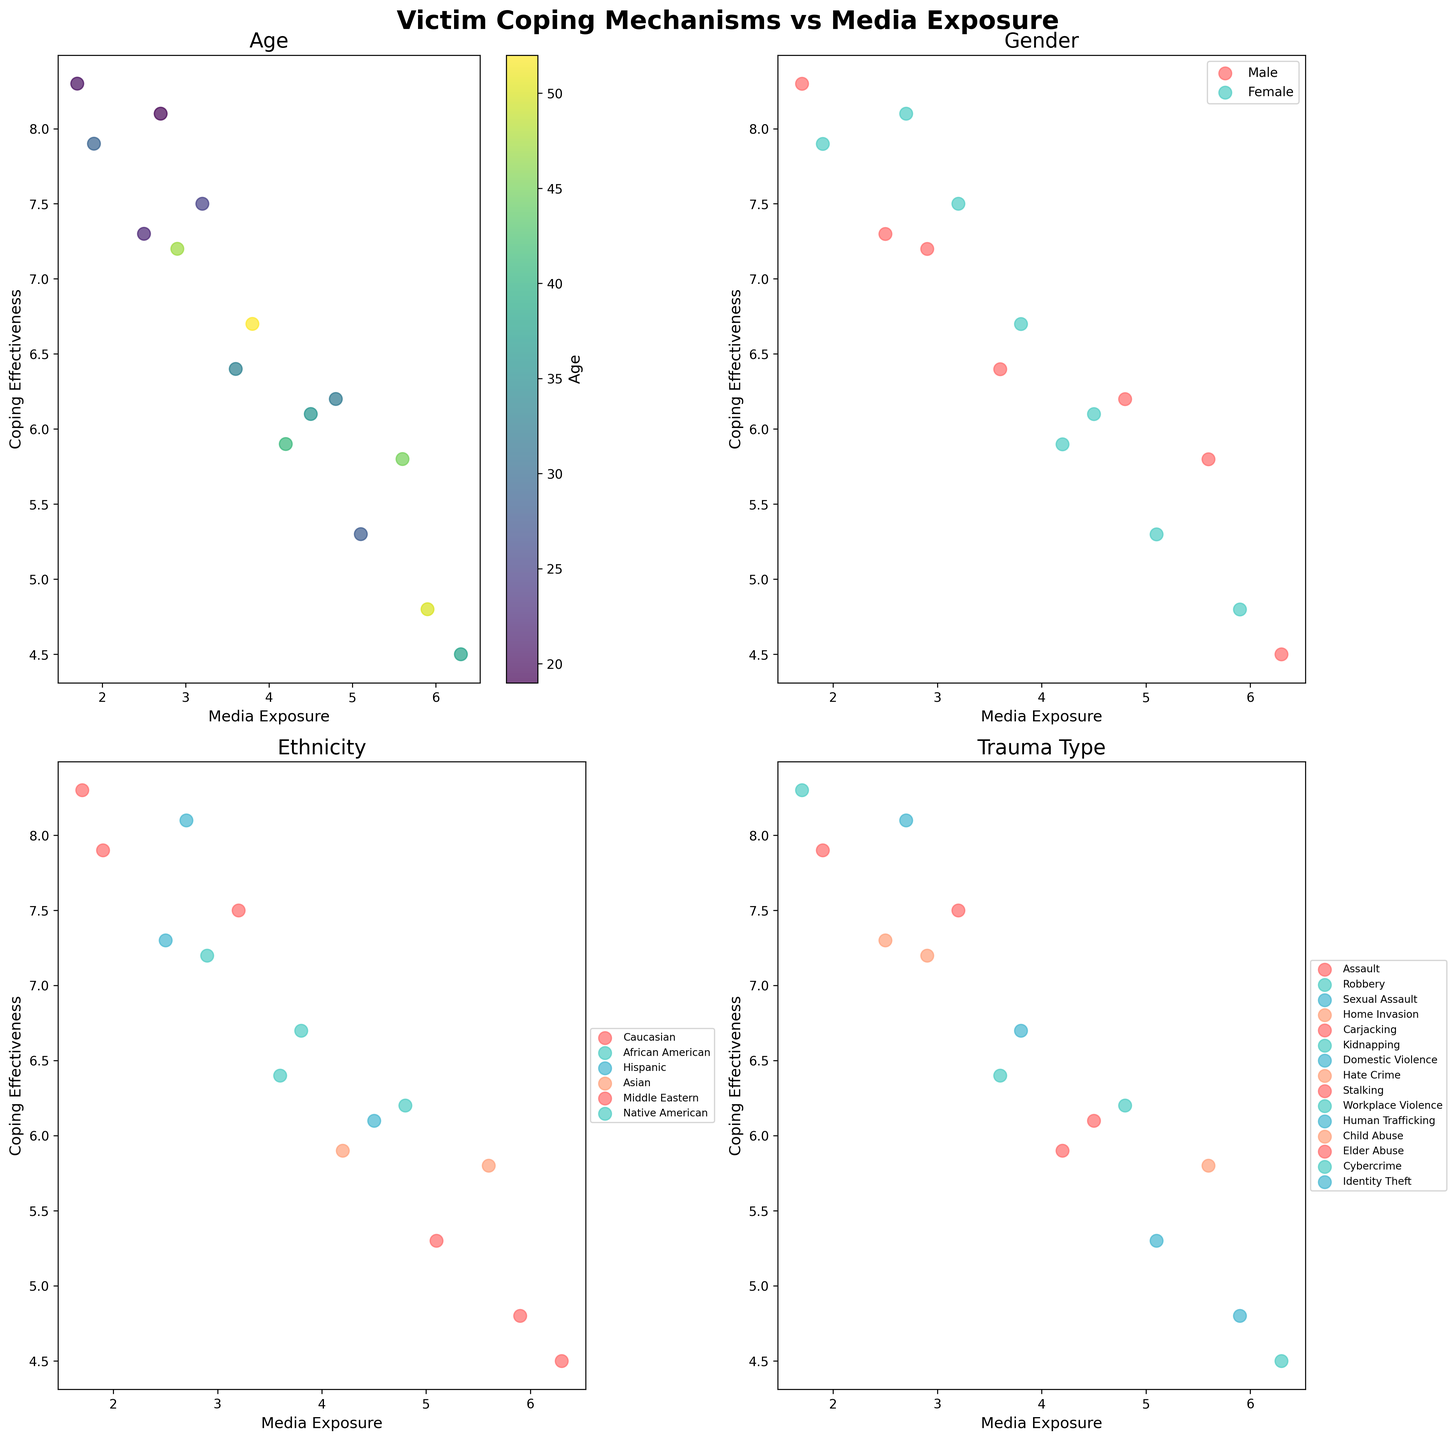What is the title of the figure? The title of the figure distinguishes and summarizes the overall content, specifically seen at the figure's top, styled prominently.
Answer: Victim Coping Mechanisms vs Media Exposure Which demographic group has the highest number of data points in the Ethnicity subplot? In the Ethnicity subplot, count the number of points associated with each unique ethnicity's color in the legend.
Answer: Caucasian How do coping effectiveness and media exposure relate for victims in the Age subplot? Examine the first subplot where Age is the variable represented by a color gradient; look for general trends or patterns in coping effectiveness relative to media exposure values.
Answer: Older victims tend to have lower coping effectiveness with higher media exposure Is there a noticeable difference in coping effectiveness between males and females based on the Gender subplot? Comparing the clustering of data points representing males and females in the Gender subplot helps identify variations in coping effectiveness.
Answer: Yes, females generally have higher coping effectiveness Which trauma type indicates the lowest coping effectiveness with high media exposure? Check the Trauma Type subplot for the data point indicating the highest media exposure and the respective coping effectiveness, paired with the legend color corresponding to trauma type.
Answer: Identity Theft Does higher media exposure always correlate with lower coping effectiveness in any subplot? Compare scatter plots across different demographics by observing whether points with high media exposure consistently show low coping effectiveness.
Answer: No, not always What is the age range displayed in the Age subplot? By observing the range of colors in the Age subplot and the corresponding color bar, infer the minimum and maximum ages among the data points.
Answer: 19 - 52 Which subplot shows the most diverse range of coping effectiveness and media exposure values? Review each subplot and compare the spread and range of data points for coping effectiveness and media exposure.
Answer: Age How does the coping effectiveness of African American victims compare to Hispanic victims given their media exposure levels? In the Ethnicity subplot, analyze and compare the coping effectiveness (y-axis) of data points associated with African American and Hispanic colors.
Answer: African American victims generally have lower coping effectiveness compared to Hispanic victims with similar media exposure levels Which gender shows a wider range of media exposure levels based on the Gender subplot? Assess the horizontal spread of points categorized by gender in the Gender subplot.
Answer: Males Do any ethnicities show a clear trend between media exposure and coping effectiveness? Evaluate the Ethnicity subplot for specific racial or ethnic groups that display a consistent trend or relationship between media exposure and coping effectiveness.
Answer: No clear trend 